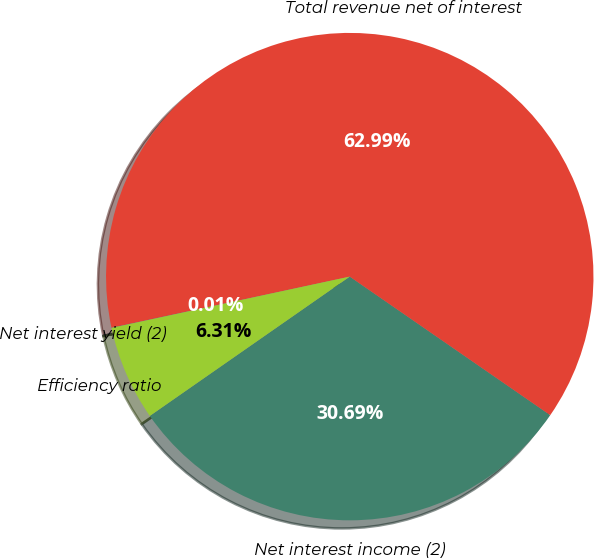Convert chart. <chart><loc_0><loc_0><loc_500><loc_500><pie_chart><fcel>Net interest income (2)<fcel>Total revenue net of interest<fcel>Net interest yield (2)<fcel>Efficiency ratio<nl><fcel>30.69%<fcel>62.99%<fcel>0.01%<fcel>6.31%<nl></chart> 